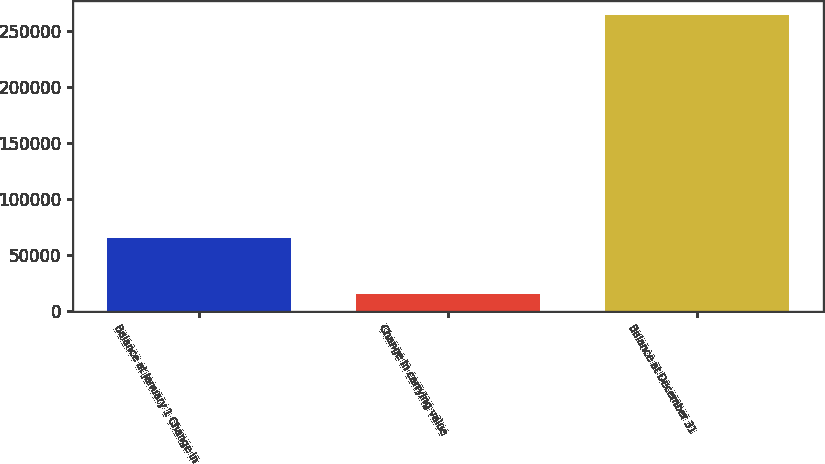Convert chart. <chart><loc_0><loc_0><loc_500><loc_500><bar_chart><fcel>Balance at January 1 Change in<fcel>Change in carrying value<fcel>Balance at December 31<nl><fcel>65524<fcel>15247<fcel>264394<nl></chart> 